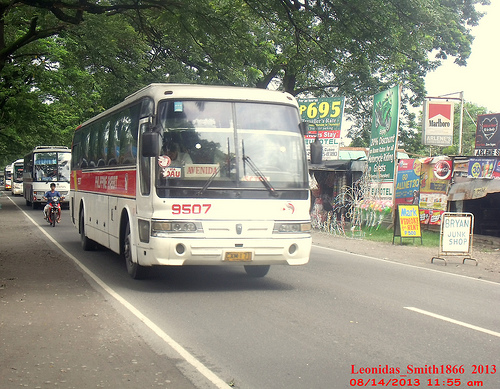Please provide the bounding box coordinate of the region this sentence describes: Man in blue shirt riding motorcycle. The bounding box coordinate for the man in a blue shirt riding a motorcycle is [0.07, 0.47, 0.14, 0.57]. 